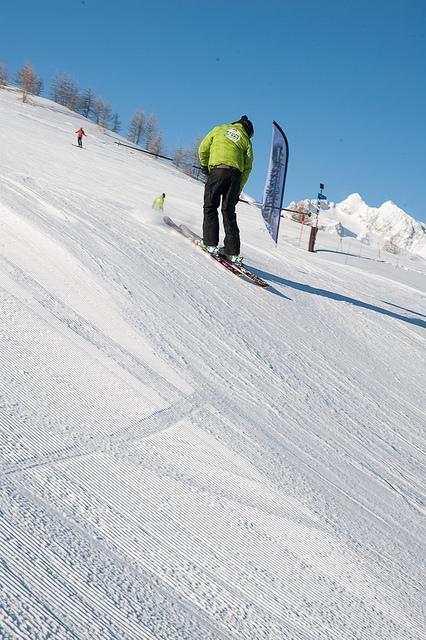How many people are skiing?
Give a very brief answer. 2. How many back fridges are in the store?
Give a very brief answer. 0. 